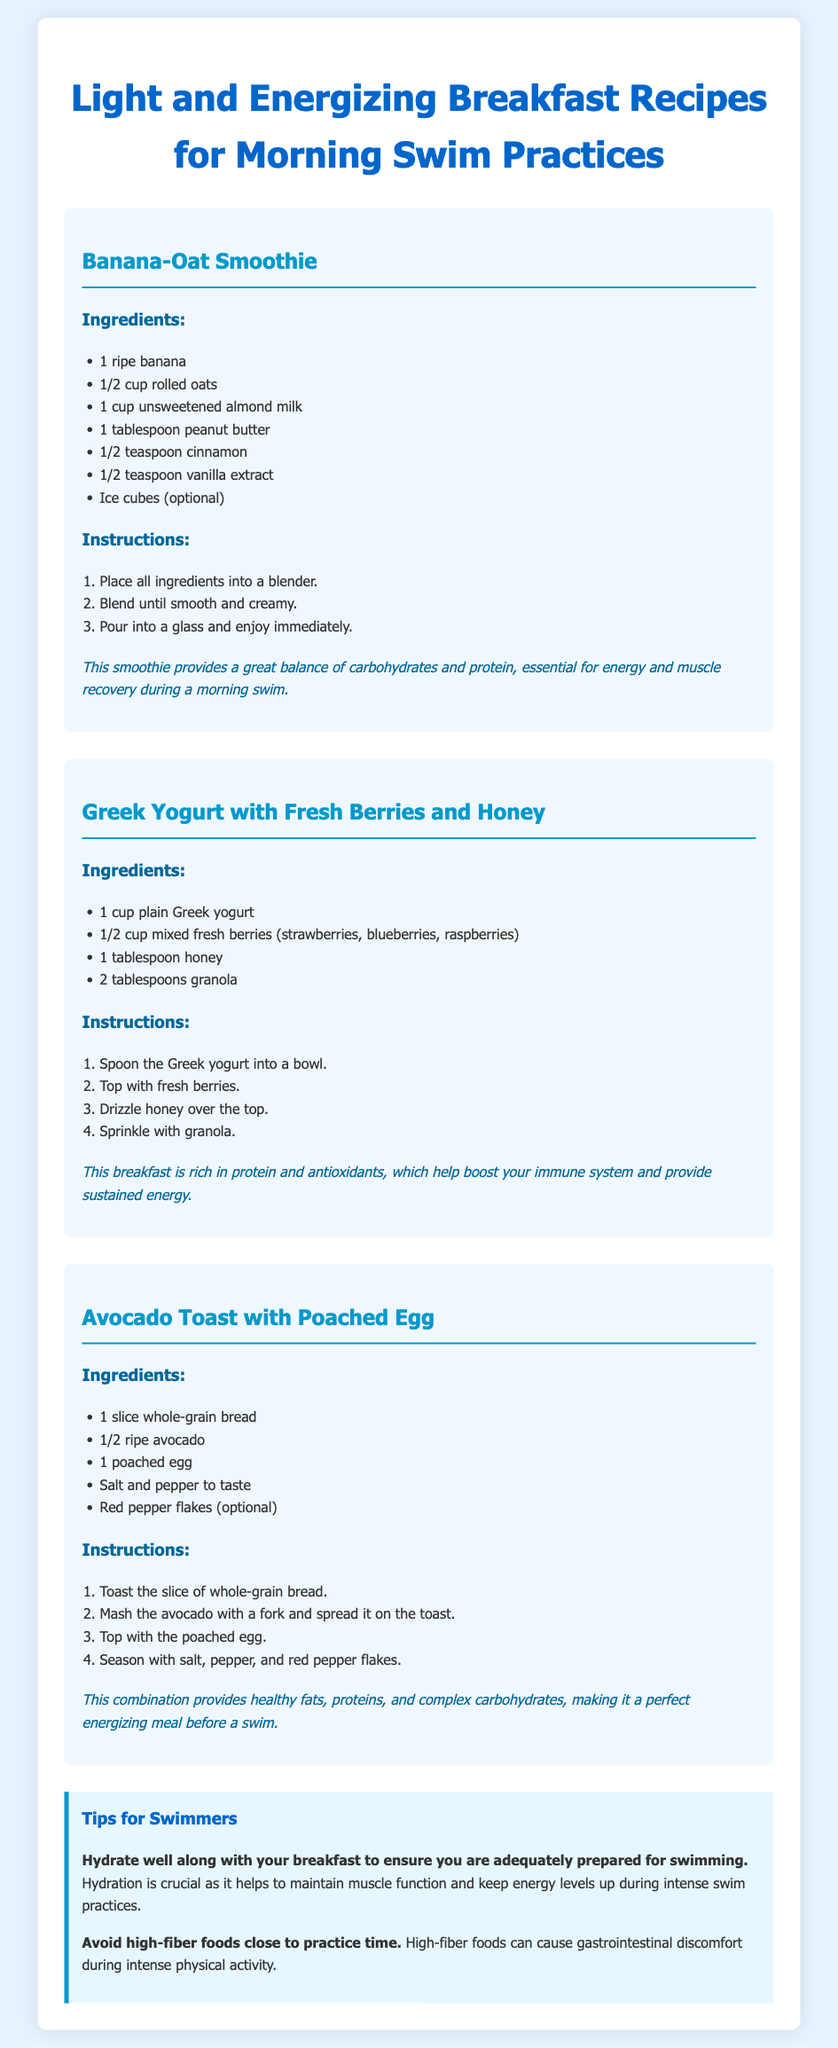What is the first recipe listed? The first recipe listed in the document is "Banana-Oat Smoothie."
Answer: Banana-Oat Smoothie How many tablespoons of honey are in the Greek Yogurt recipe? The Greek Yogurt recipe requires 1 tablespoon of honey.
Answer: 1 tablespoon What is one optional ingredient for the Avocado Toast? The optional ingredient mentioned for the Avocado Toast is "Red pepper flakes."
Answer: Red pepper flakes What is a benefit of the Banana-Oat Smoothie? The document states that the smoothie provides a great balance of carbohydrates and protein, essential for energy and muscle recovery during a morning swim.
Answer: Energy and muscle recovery What should swimmers hydrate with along with breakfast? The tips section emphasizes that swimmers should hydrate well along with their breakfast.
Answer: Water What kind of bread is used in the Avocado Toast? The recipe indicates that "whole-grain bread" is used for the Avocado Toast.
Answer: Whole-grain bread How many servings of mixed berries are suggested in the Greek Yogurt recipe? The Greek Yogurt recipe suggests using 1/2 cup of mixed fresh berries.
Answer: 1/2 cup What is one benefit of the Greek Yogurt breakfast? The document mentions that this breakfast is rich in protein and antioxidants, providing sustained energy.
Answer: Sustained energy What is advised against consuming close to practice time? The document advises to avoid high-fiber foods close to practice time.
Answer: High-fiber foods 